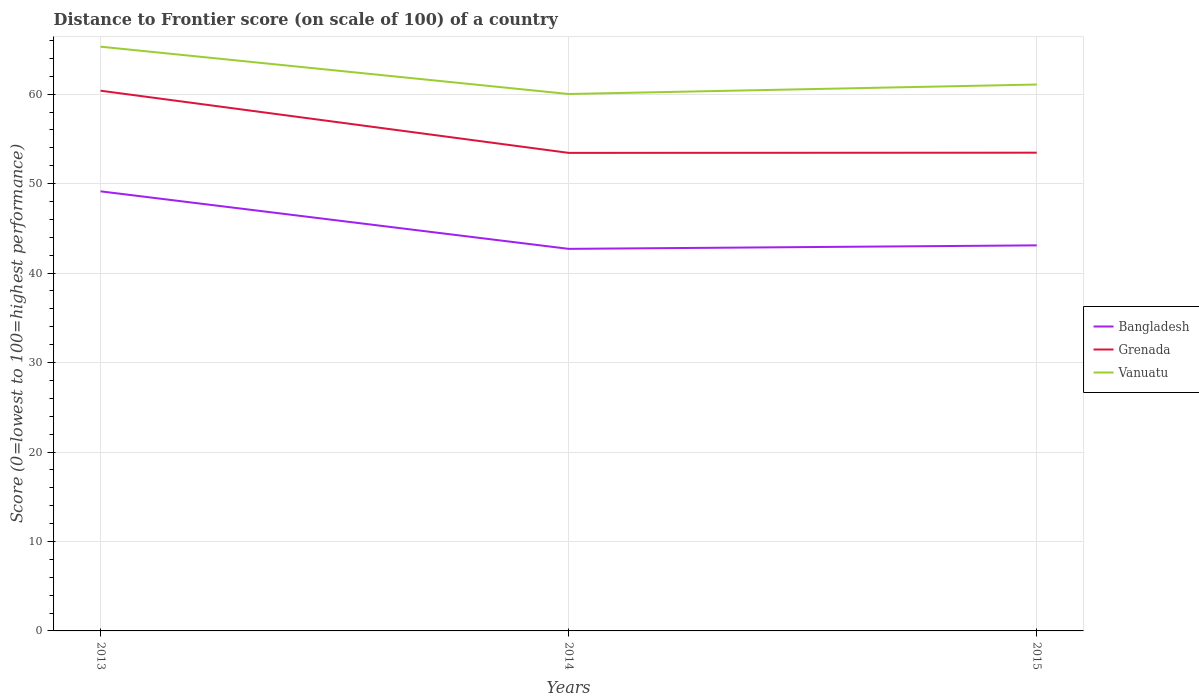Across all years, what is the maximum distance to frontier score of in Bangladesh?
Offer a very short reply. 42.71. In which year was the distance to frontier score of in Grenada maximum?
Provide a succinct answer. 2014. What is the total distance to frontier score of in Grenada in the graph?
Offer a terse response. -0.02. What is the difference between the highest and the second highest distance to frontier score of in Vanuatu?
Offer a very short reply. 5.29. What is the difference between the highest and the lowest distance to frontier score of in Vanuatu?
Ensure brevity in your answer.  1. Is the distance to frontier score of in Grenada strictly greater than the distance to frontier score of in Vanuatu over the years?
Ensure brevity in your answer.  Yes. How many years are there in the graph?
Offer a terse response. 3. What is the difference between two consecutive major ticks on the Y-axis?
Your answer should be very brief. 10. Are the values on the major ticks of Y-axis written in scientific E-notation?
Keep it short and to the point. No. Does the graph contain grids?
Your answer should be compact. Yes. Where does the legend appear in the graph?
Your response must be concise. Center right. What is the title of the graph?
Ensure brevity in your answer.  Distance to Frontier score (on scale of 100) of a country. Does "Albania" appear as one of the legend labels in the graph?
Provide a short and direct response. No. What is the label or title of the Y-axis?
Make the answer very short. Score (0=lowest to 100=highest performance). What is the Score (0=lowest to 100=highest performance) in Bangladesh in 2013?
Your answer should be very brief. 49.14. What is the Score (0=lowest to 100=highest performance) of Grenada in 2013?
Keep it short and to the point. 60.39. What is the Score (0=lowest to 100=highest performance) in Vanuatu in 2013?
Offer a very short reply. 65.31. What is the Score (0=lowest to 100=highest performance) in Bangladesh in 2014?
Your answer should be compact. 42.71. What is the Score (0=lowest to 100=highest performance) in Grenada in 2014?
Ensure brevity in your answer.  53.44. What is the Score (0=lowest to 100=highest performance) in Vanuatu in 2014?
Provide a succinct answer. 60.02. What is the Score (0=lowest to 100=highest performance) of Bangladesh in 2015?
Offer a terse response. 43.1. What is the Score (0=lowest to 100=highest performance) of Grenada in 2015?
Offer a very short reply. 53.46. What is the Score (0=lowest to 100=highest performance) in Vanuatu in 2015?
Give a very brief answer. 61.08. Across all years, what is the maximum Score (0=lowest to 100=highest performance) of Bangladesh?
Provide a short and direct response. 49.14. Across all years, what is the maximum Score (0=lowest to 100=highest performance) in Grenada?
Your answer should be very brief. 60.39. Across all years, what is the maximum Score (0=lowest to 100=highest performance) of Vanuatu?
Your answer should be compact. 65.31. Across all years, what is the minimum Score (0=lowest to 100=highest performance) in Bangladesh?
Keep it short and to the point. 42.71. Across all years, what is the minimum Score (0=lowest to 100=highest performance) in Grenada?
Your answer should be compact. 53.44. Across all years, what is the minimum Score (0=lowest to 100=highest performance) in Vanuatu?
Offer a terse response. 60.02. What is the total Score (0=lowest to 100=highest performance) in Bangladesh in the graph?
Make the answer very short. 134.95. What is the total Score (0=lowest to 100=highest performance) of Grenada in the graph?
Your answer should be compact. 167.29. What is the total Score (0=lowest to 100=highest performance) in Vanuatu in the graph?
Make the answer very short. 186.41. What is the difference between the Score (0=lowest to 100=highest performance) in Bangladesh in 2013 and that in 2014?
Your answer should be very brief. 6.43. What is the difference between the Score (0=lowest to 100=highest performance) in Grenada in 2013 and that in 2014?
Offer a terse response. 6.95. What is the difference between the Score (0=lowest to 100=highest performance) of Vanuatu in 2013 and that in 2014?
Your response must be concise. 5.29. What is the difference between the Score (0=lowest to 100=highest performance) of Bangladesh in 2013 and that in 2015?
Keep it short and to the point. 6.04. What is the difference between the Score (0=lowest to 100=highest performance) of Grenada in 2013 and that in 2015?
Provide a succinct answer. 6.93. What is the difference between the Score (0=lowest to 100=highest performance) in Vanuatu in 2013 and that in 2015?
Ensure brevity in your answer.  4.23. What is the difference between the Score (0=lowest to 100=highest performance) in Bangladesh in 2014 and that in 2015?
Provide a succinct answer. -0.39. What is the difference between the Score (0=lowest to 100=highest performance) in Grenada in 2014 and that in 2015?
Offer a terse response. -0.02. What is the difference between the Score (0=lowest to 100=highest performance) in Vanuatu in 2014 and that in 2015?
Provide a succinct answer. -1.06. What is the difference between the Score (0=lowest to 100=highest performance) of Bangladesh in 2013 and the Score (0=lowest to 100=highest performance) of Grenada in 2014?
Offer a terse response. -4.3. What is the difference between the Score (0=lowest to 100=highest performance) of Bangladesh in 2013 and the Score (0=lowest to 100=highest performance) of Vanuatu in 2014?
Provide a succinct answer. -10.88. What is the difference between the Score (0=lowest to 100=highest performance) of Grenada in 2013 and the Score (0=lowest to 100=highest performance) of Vanuatu in 2014?
Your response must be concise. 0.37. What is the difference between the Score (0=lowest to 100=highest performance) in Bangladesh in 2013 and the Score (0=lowest to 100=highest performance) in Grenada in 2015?
Keep it short and to the point. -4.32. What is the difference between the Score (0=lowest to 100=highest performance) in Bangladesh in 2013 and the Score (0=lowest to 100=highest performance) in Vanuatu in 2015?
Your answer should be very brief. -11.94. What is the difference between the Score (0=lowest to 100=highest performance) in Grenada in 2013 and the Score (0=lowest to 100=highest performance) in Vanuatu in 2015?
Make the answer very short. -0.69. What is the difference between the Score (0=lowest to 100=highest performance) in Bangladesh in 2014 and the Score (0=lowest to 100=highest performance) in Grenada in 2015?
Provide a succinct answer. -10.75. What is the difference between the Score (0=lowest to 100=highest performance) of Bangladesh in 2014 and the Score (0=lowest to 100=highest performance) of Vanuatu in 2015?
Offer a very short reply. -18.37. What is the difference between the Score (0=lowest to 100=highest performance) of Grenada in 2014 and the Score (0=lowest to 100=highest performance) of Vanuatu in 2015?
Provide a succinct answer. -7.64. What is the average Score (0=lowest to 100=highest performance) of Bangladesh per year?
Offer a very short reply. 44.98. What is the average Score (0=lowest to 100=highest performance) of Grenada per year?
Keep it short and to the point. 55.76. What is the average Score (0=lowest to 100=highest performance) of Vanuatu per year?
Ensure brevity in your answer.  62.14. In the year 2013, what is the difference between the Score (0=lowest to 100=highest performance) of Bangladesh and Score (0=lowest to 100=highest performance) of Grenada?
Ensure brevity in your answer.  -11.25. In the year 2013, what is the difference between the Score (0=lowest to 100=highest performance) in Bangladesh and Score (0=lowest to 100=highest performance) in Vanuatu?
Provide a short and direct response. -16.17. In the year 2013, what is the difference between the Score (0=lowest to 100=highest performance) of Grenada and Score (0=lowest to 100=highest performance) of Vanuatu?
Offer a very short reply. -4.92. In the year 2014, what is the difference between the Score (0=lowest to 100=highest performance) in Bangladesh and Score (0=lowest to 100=highest performance) in Grenada?
Your answer should be compact. -10.73. In the year 2014, what is the difference between the Score (0=lowest to 100=highest performance) in Bangladesh and Score (0=lowest to 100=highest performance) in Vanuatu?
Your answer should be compact. -17.31. In the year 2014, what is the difference between the Score (0=lowest to 100=highest performance) of Grenada and Score (0=lowest to 100=highest performance) of Vanuatu?
Your answer should be very brief. -6.58. In the year 2015, what is the difference between the Score (0=lowest to 100=highest performance) in Bangladesh and Score (0=lowest to 100=highest performance) in Grenada?
Your answer should be compact. -10.36. In the year 2015, what is the difference between the Score (0=lowest to 100=highest performance) in Bangladesh and Score (0=lowest to 100=highest performance) in Vanuatu?
Give a very brief answer. -17.98. In the year 2015, what is the difference between the Score (0=lowest to 100=highest performance) of Grenada and Score (0=lowest to 100=highest performance) of Vanuatu?
Provide a succinct answer. -7.62. What is the ratio of the Score (0=lowest to 100=highest performance) in Bangladesh in 2013 to that in 2014?
Your answer should be compact. 1.15. What is the ratio of the Score (0=lowest to 100=highest performance) in Grenada in 2013 to that in 2014?
Ensure brevity in your answer.  1.13. What is the ratio of the Score (0=lowest to 100=highest performance) of Vanuatu in 2013 to that in 2014?
Offer a very short reply. 1.09. What is the ratio of the Score (0=lowest to 100=highest performance) of Bangladesh in 2013 to that in 2015?
Provide a short and direct response. 1.14. What is the ratio of the Score (0=lowest to 100=highest performance) in Grenada in 2013 to that in 2015?
Your answer should be very brief. 1.13. What is the ratio of the Score (0=lowest to 100=highest performance) of Vanuatu in 2013 to that in 2015?
Your answer should be compact. 1.07. What is the ratio of the Score (0=lowest to 100=highest performance) of Bangladesh in 2014 to that in 2015?
Your answer should be very brief. 0.99. What is the ratio of the Score (0=lowest to 100=highest performance) of Grenada in 2014 to that in 2015?
Give a very brief answer. 1. What is the ratio of the Score (0=lowest to 100=highest performance) in Vanuatu in 2014 to that in 2015?
Provide a succinct answer. 0.98. What is the difference between the highest and the second highest Score (0=lowest to 100=highest performance) of Bangladesh?
Your response must be concise. 6.04. What is the difference between the highest and the second highest Score (0=lowest to 100=highest performance) of Grenada?
Your answer should be compact. 6.93. What is the difference between the highest and the second highest Score (0=lowest to 100=highest performance) of Vanuatu?
Provide a short and direct response. 4.23. What is the difference between the highest and the lowest Score (0=lowest to 100=highest performance) of Bangladesh?
Your answer should be compact. 6.43. What is the difference between the highest and the lowest Score (0=lowest to 100=highest performance) of Grenada?
Your answer should be very brief. 6.95. What is the difference between the highest and the lowest Score (0=lowest to 100=highest performance) of Vanuatu?
Offer a very short reply. 5.29. 